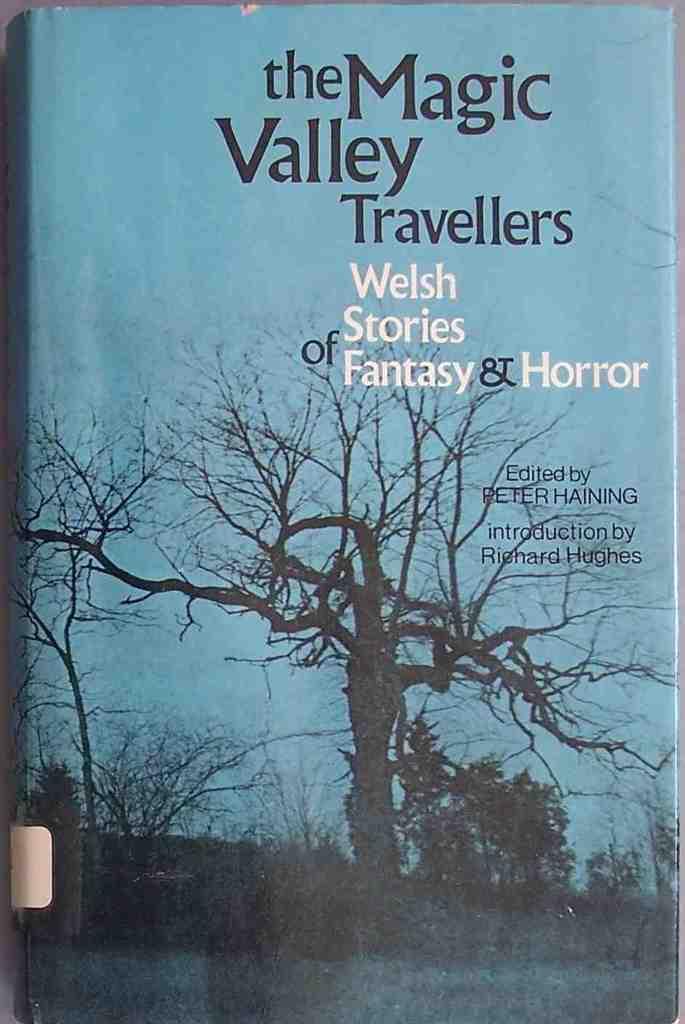What type of stores are in the book?
Give a very brief answer. Welsh stories of fantasy & horror. What is the book title?
Provide a short and direct response. The magic valley travellers. 